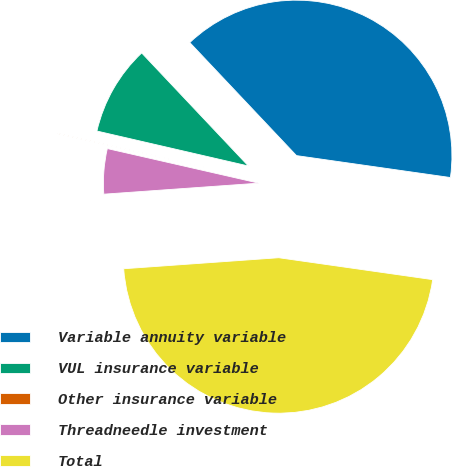Convert chart. <chart><loc_0><loc_0><loc_500><loc_500><pie_chart><fcel>Variable annuity variable<fcel>VUL insurance variable<fcel>Other insurance variable<fcel>Threadneedle investment<fcel>Total<nl><fcel>39.29%<fcel>9.35%<fcel>0.04%<fcel>4.7%<fcel>46.62%<nl></chart> 